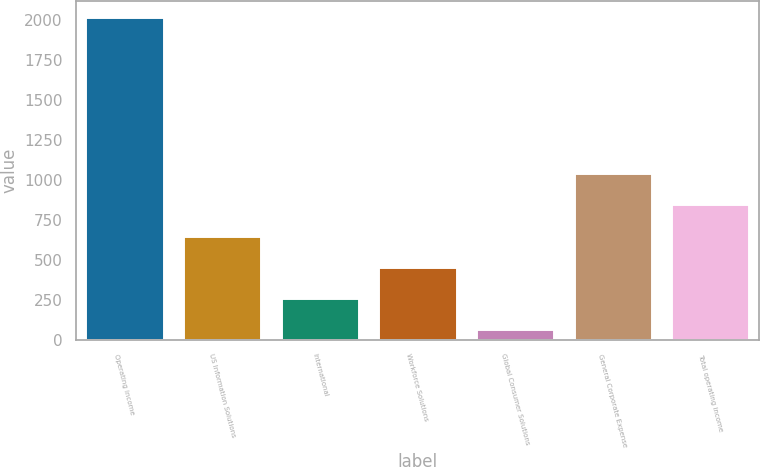Convert chart. <chart><loc_0><loc_0><loc_500><loc_500><bar_chart><fcel>Operating income<fcel>US Information Solutions<fcel>International<fcel>Workforce Solutions<fcel>Global Consumer Solutions<fcel>General Corporate Expense<fcel>Total operating income<nl><fcel>2018<fcel>653.42<fcel>263.54<fcel>458.48<fcel>68.6<fcel>1043.3<fcel>848.36<nl></chart> 